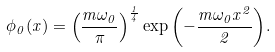<formula> <loc_0><loc_0><loc_500><loc_500>\phi _ { 0 } ( x ) = \left ( \frac { m \omega _ { 0 } } { \pi } \right ) ^ { \frac { 1 } { 4 } } \exp { \left ( - \frac { m \omega _ { 0 } x ^ { 2 } } { 2 } \right ) } .</formula> 